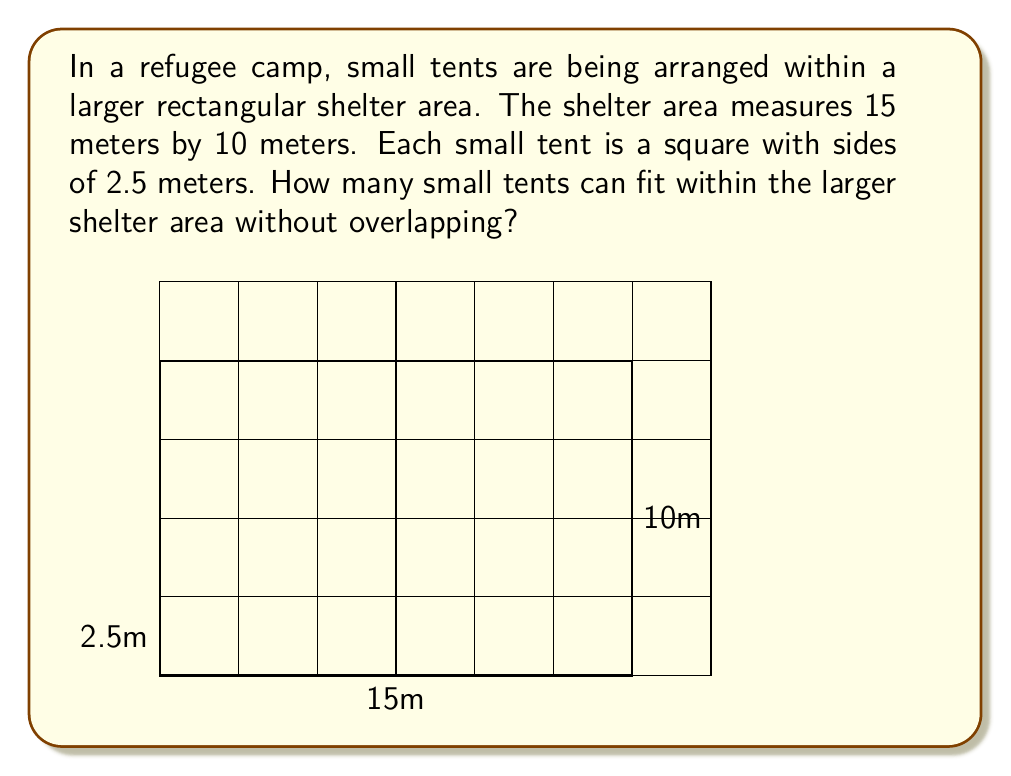Can you answer this question? To solve this problem, we need to follow these steps:

1) Calculate the area of the larger shelter:
   $$ A_{shelter} = 15\text{ m} \times 10\text{ m} = 150\text{ m}^2 $$

2) Calculate the area of each small tent:
   $$ A_{tent} = 2.5\text{ m} \times 2.5\text{ m} = 6.25\text{ m}^2 $$

3) Divide the shelter area by the tent area:
   $$ \frac{A_{shelter}}{A_{tent}} = \frac{150\text{ m}^2}{6.25\text{ m}^2} = 24 $$

4) However, we need to consider that tents must fit in whole numbers along each dimension:
   - Along the 15m side: $15 \div 2.5 = 6$ tents
   - Along the 10m side: $10 \div 2.5 = 4$ tents

5) Multiply these numbers:
   $$ 6 \times 4 = 24 \text{ tents} $$

This matches our calculation in step 3, confirming that 24 tents can fit without any wasted space.
Answer: 24 tents 